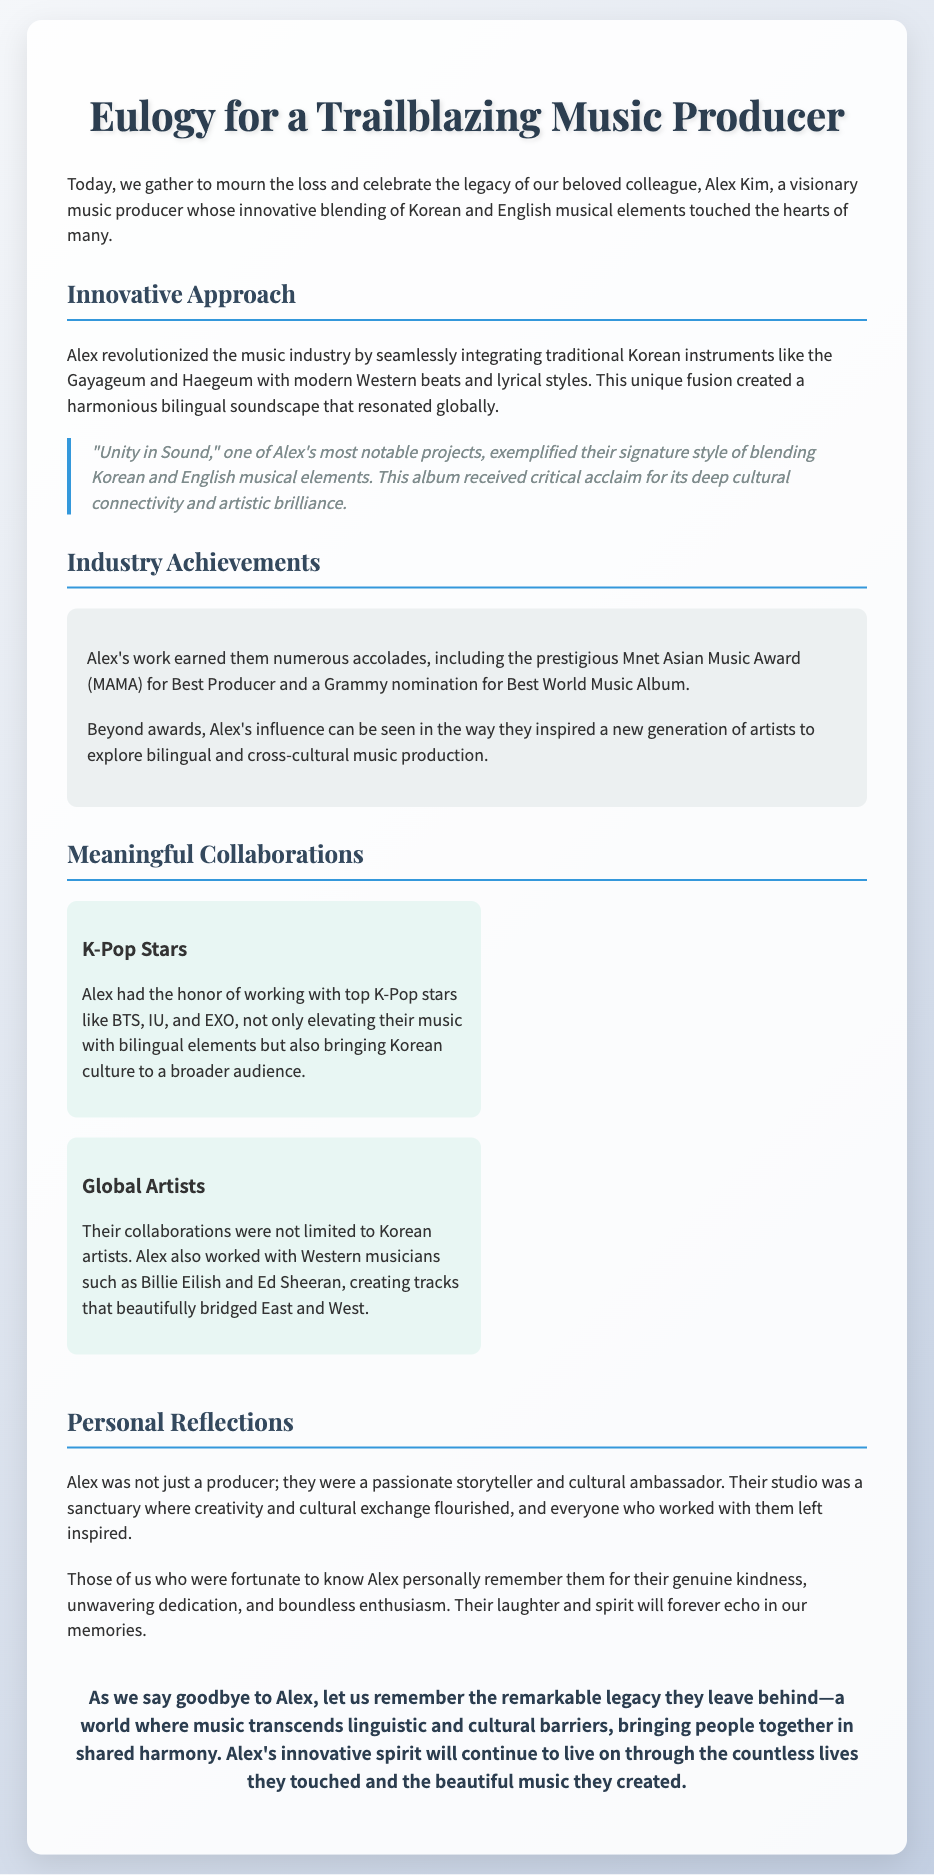What is the title of the eulogy? The title of the eulogy is "Eulogy for a Trailblazing Music Producer".
Answer: Eulogy for a Trailblazing Music Producer Who is the eulogy for? The eulogy is for Alex Kim, a music producer.
Answer: Alex Kim What award did Alex Kim receive for their work? Alex received the prestigious Mnet Asian Music Award (MAMA) for Best Producer.
Answer: Best Producer Which K-Pop stars did Alex collaborate with? Alex collaborated with BTS, IU, and EXO among others.
Answer: BTS, IU, EXO What was one of Alex's notable projects? One of Alex's notable projects was "Unity in Sound".
Answer: Unity in Sound How did Alex's work influence other artists? Alex inspired a new generation of artists to explore bilingual and cross-cultural music production.
Answer: Inspired a new generation What was Alex described as in relation to their cultural impact? Alex was described as a passionate storyteller and cultural ambassador.
Answer: Cultural ambassador Which Western artists did Alex work with? Alex worked with Billie Eilish and Ed Sheeran.
Answer: Billie Eilish and Ed Sheeran What was the impact of Alex's music according to the conclusion? Alex's music transcended linguistic and cultural barriers.
Answer: Transcended barriers 